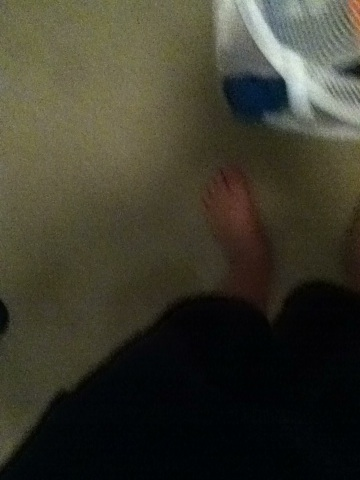What is this picture of? This image appears to show a person's bare feet and lower legs, standing on a carpeted floor next to a white plastic basket with blue and possibly other colored contents. 